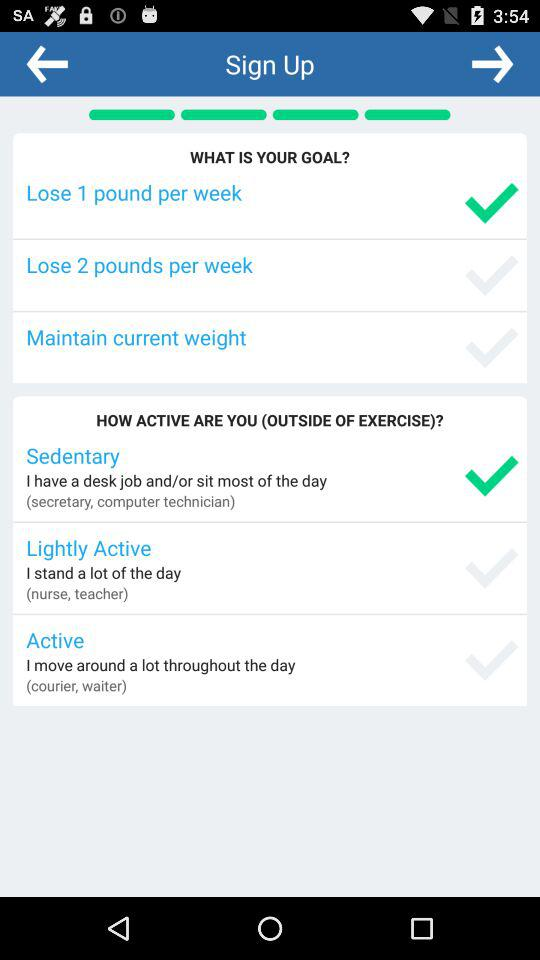Which option is selected in "How active are you"? The selected option is "Sedentary". 